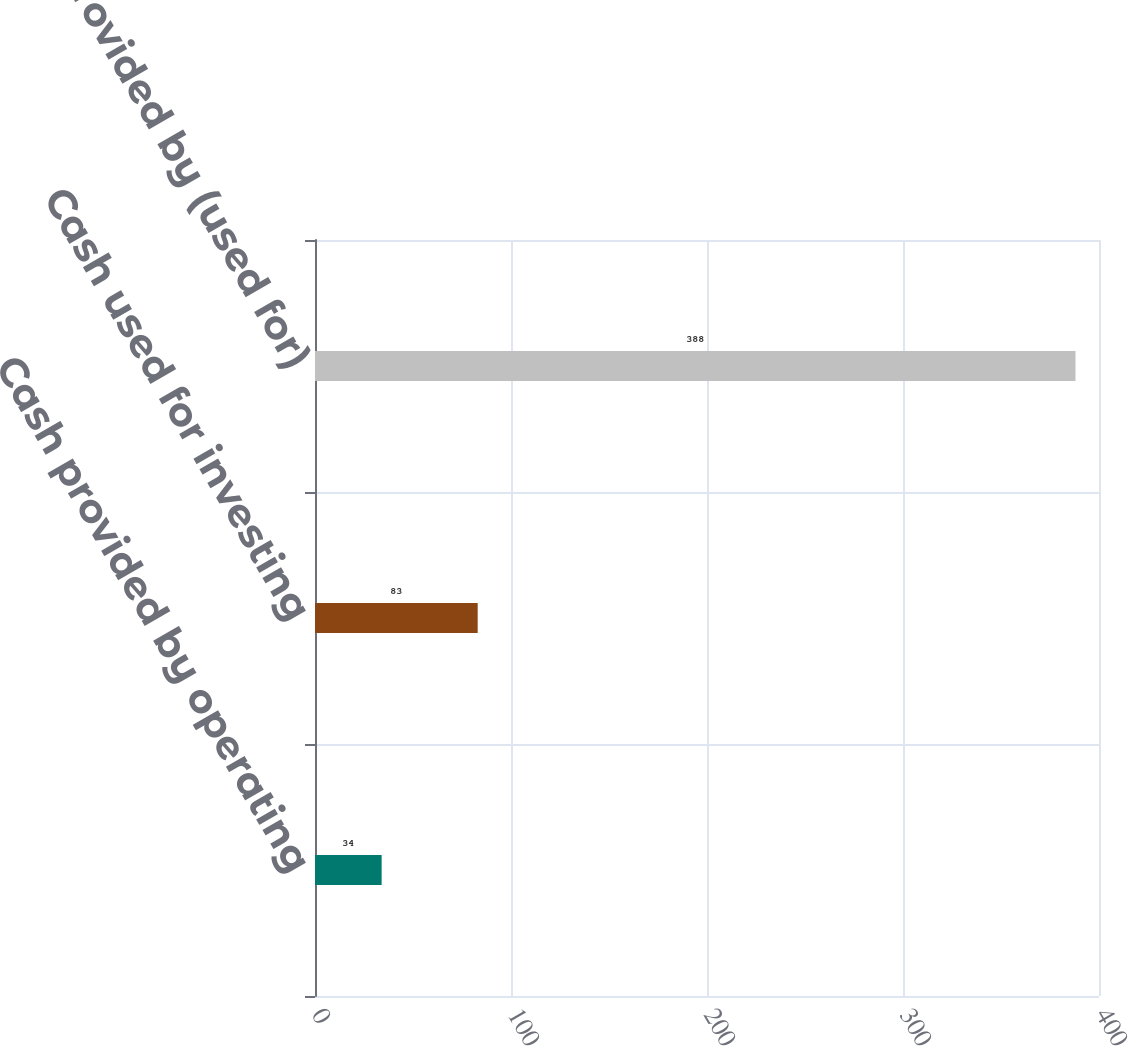Convert chart. <chart><loc_0><loc_0><loc_500><loc_500><bar_chart><fcel>Cash provided by operating<fcel>Cash used for investing<fcel>Cash provided by (used for)<nl><fcel>34<fcel>83<fcel>388<nl></chart> 